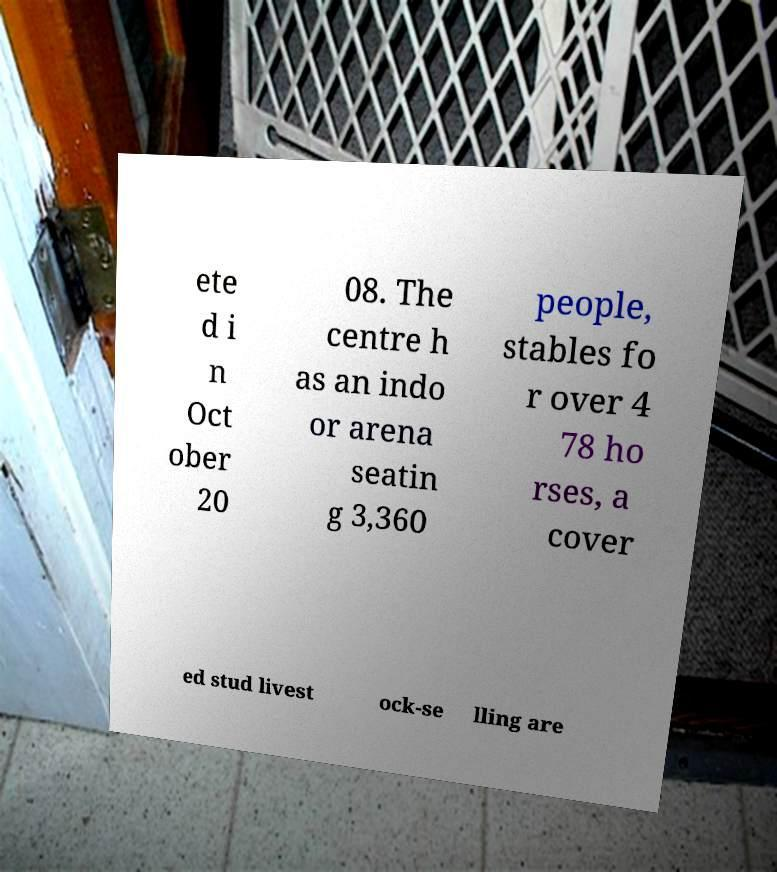Can you accurately transcribe the text from the provided image for me? ete d i n Oct ober 20 08. The centre h as an indo or arena seatin g 3,360 people, stables fo r over 4 78 ho rses, a cover ed stud livest ock-se lling are 